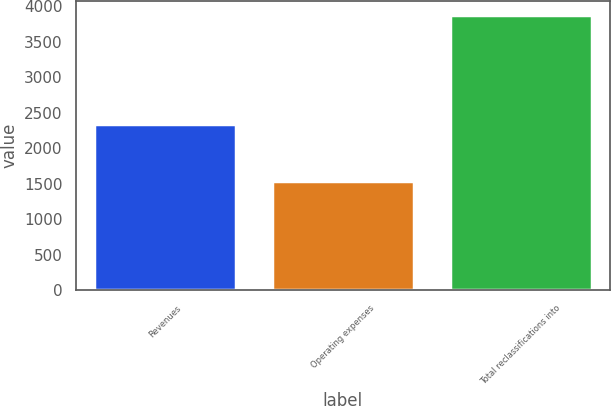Convert chart to OTSL. <chart><loc_0><loc_0><loc_500><loc_500><bar_chart><fcel>Revenues<fcel>Operating expenses<fcel>Total reclassifications into<nl><fcel>2339<fcel>1543<fcel>3882<nl></chart> 